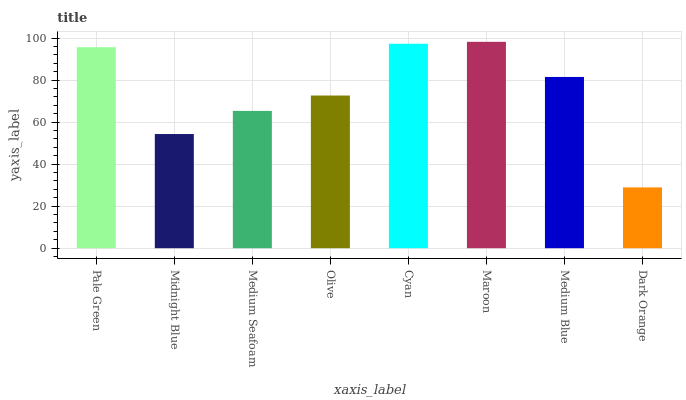Is Dark Orange the minimum?
Answer yes or no. Yes. Is Maroon the maximum?
Answer yes or no. Yes. Is Midnight Blue the minimum?
Answer yes or no. No. Is Midnight Blue the maximum?
Answer yes or no. No. Is Pale Green greater than Midnight Blue?
Answer yes or no. Yes. Is Midnight Blue less than Pale Green?
Answer yes or no. Yes. Is Midnight Blue greater than Pale Green?
Answer yes or no. No. Is Pale Green less than Midnight Blue?
Answer yes or no. No. Is Medium Blue the high median?
Answer yes or no. Yes. Is Olive the low median?
Answer yes or no. Yes. Is Cyan the high median?
Answer yes or no. No. Is Medium Seafoam the low median?
Answer yes or no. No. 